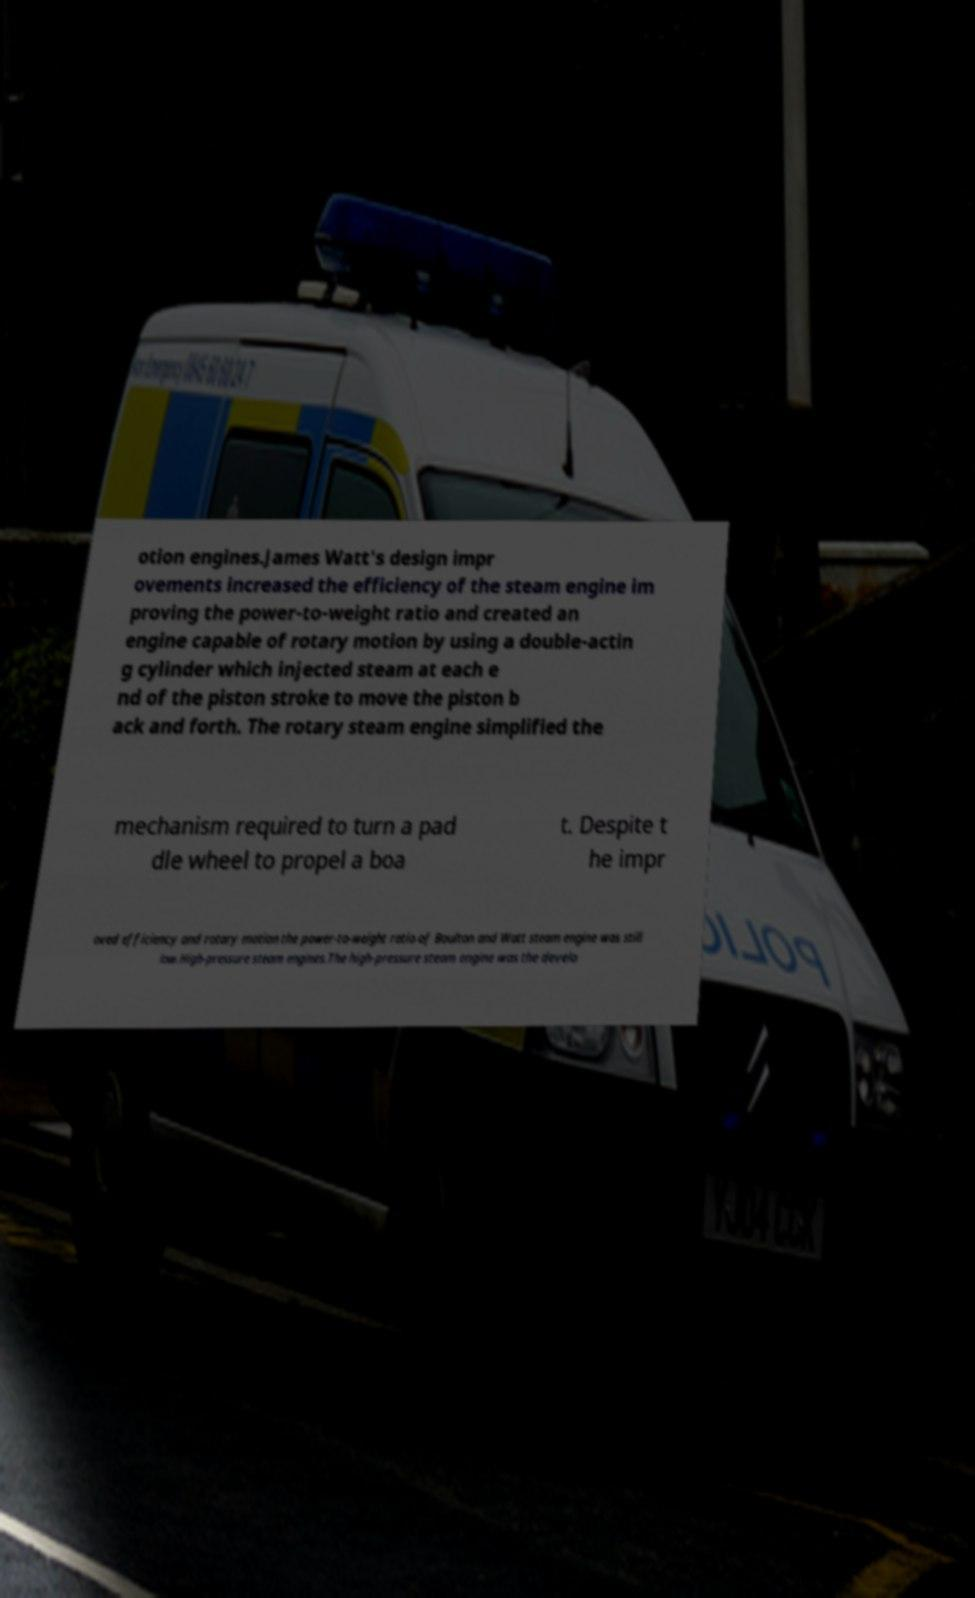Could you assist in decoding the text presented in this image and type it out clearly? otion engines.James Watt's design impr ovements increased the efficiency of the steam engine im proving the power-to-weight ratio and created an engine capable of rotary motion by using a double-actin g cylinder which injected steam at each e nd of the piston stroke to move the piston b ack and forth. The rotary steam engine simplified the mechanism required to turn a pad dle wheel to propel a boa t. Despite t he impr oved efficiency and rotary motion the power-to-weight ratio of Boulton and Watt steam engine was still low.High-pressure steam engines.The high-pressure steam engine was the develo 